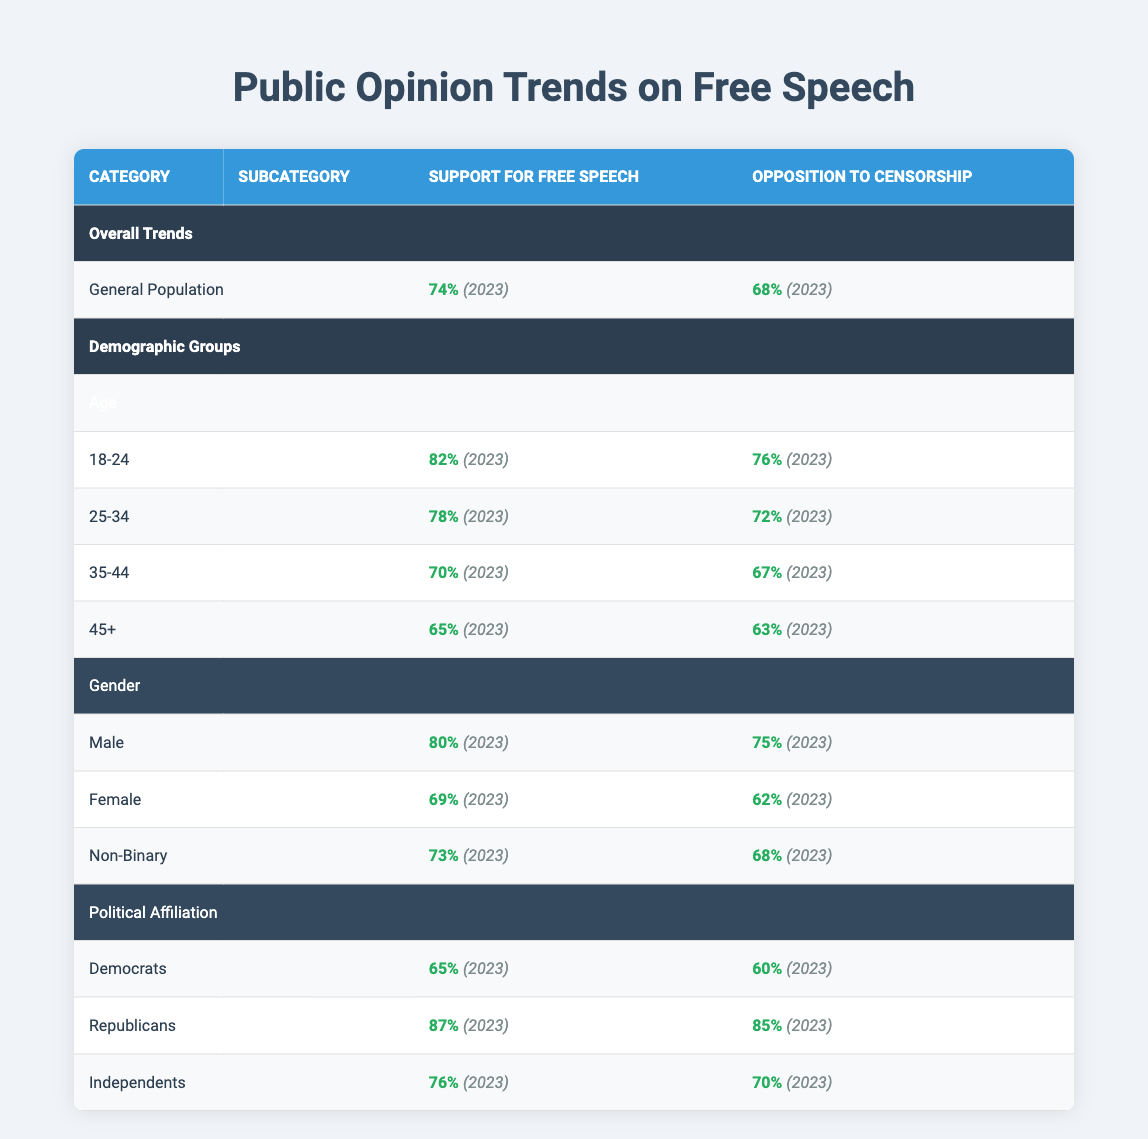What percentage of the overall population supports free speech in 2023? The table shows that the overall percentage of the population that supports free speech is listed under the "Overall Trends" section. It states 74%.
Answer: 74% What is the opposition to censorship among the 35-44 age group? According to the table, the opposition to censorship for the 35-44 age group is provided directly in their demographic row, and it is 67%.
Answer: 67% Which demographic group has the highest support for free speech? By comparing the support for free speech percentages across the age, gender, and political affiliation rows, Republicans are shown to have the highest support at 87%.
Answer: 87% Is it true that the majority of females oppose censorship according to the data? The data for females show that 62% oppose censorship, which is indeed above 50%. Thus, the statement is true.
Answer: Yes What is the difference in support for free speech between males and females? The table indicates that males have a support percentage of 80% while females have 69%. To find the difference, subtract 69 from 80, which equals 11%.
Answer: 11% What is the average support for free speech across all age groups? The support percentages for the age groups are: 82% for 18-24, 78% for 25-34, 70% for 35-44, and 65% for 45+. Summing these values gives 82 + 78 + 70 + 65 = 295, and dividing by the number of groups (4) results in an average of 73.75%.
Answer: 73.75% What is the opposition to censorship for Democrats in 2023, and how does it compare to Republicans? The table shows that Democrats have an opposition percentage of 60%, while Republicans have a higher opposition percentage of 85%. Therefore, Republicans have 25% more opposition to censorship than Democrats.
Answer: 60%; 25% How many demographic groups show a support level for free speech above 70%? The groups and their support levels indicate support above 70% includes: 18-24 (82%), 25-34 (78%), Male (80%), Republicans (87%), and Independents (76%). Counting these, there are five groups.
Answer: 5 What percentage of the 45+ age group opposes censorship? The data for the 45+ age group indicates that opposition to censorship is 63%. This specific value is mentioned directly under their demographic row.
Answer: 63% 